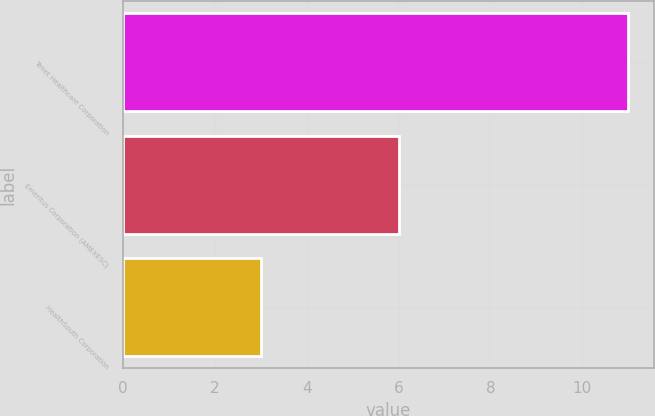Convert chart. <chart><loc_0><loc_0><loc_500><loc_500><bar_chart><fcel>Tenet Healthcare Corporation<fcel>Emeritus Corporation (AMEXESC)<fcel>HealthSouth Corporation<nl><fcel>11<fcel>6<fcel>3<nl></chart> 